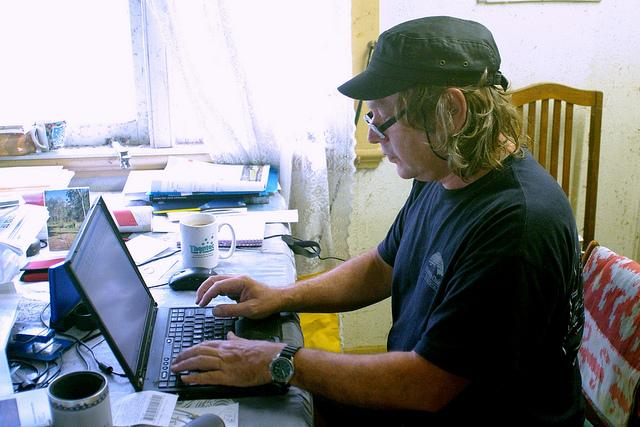Approximately what time is it? noon 